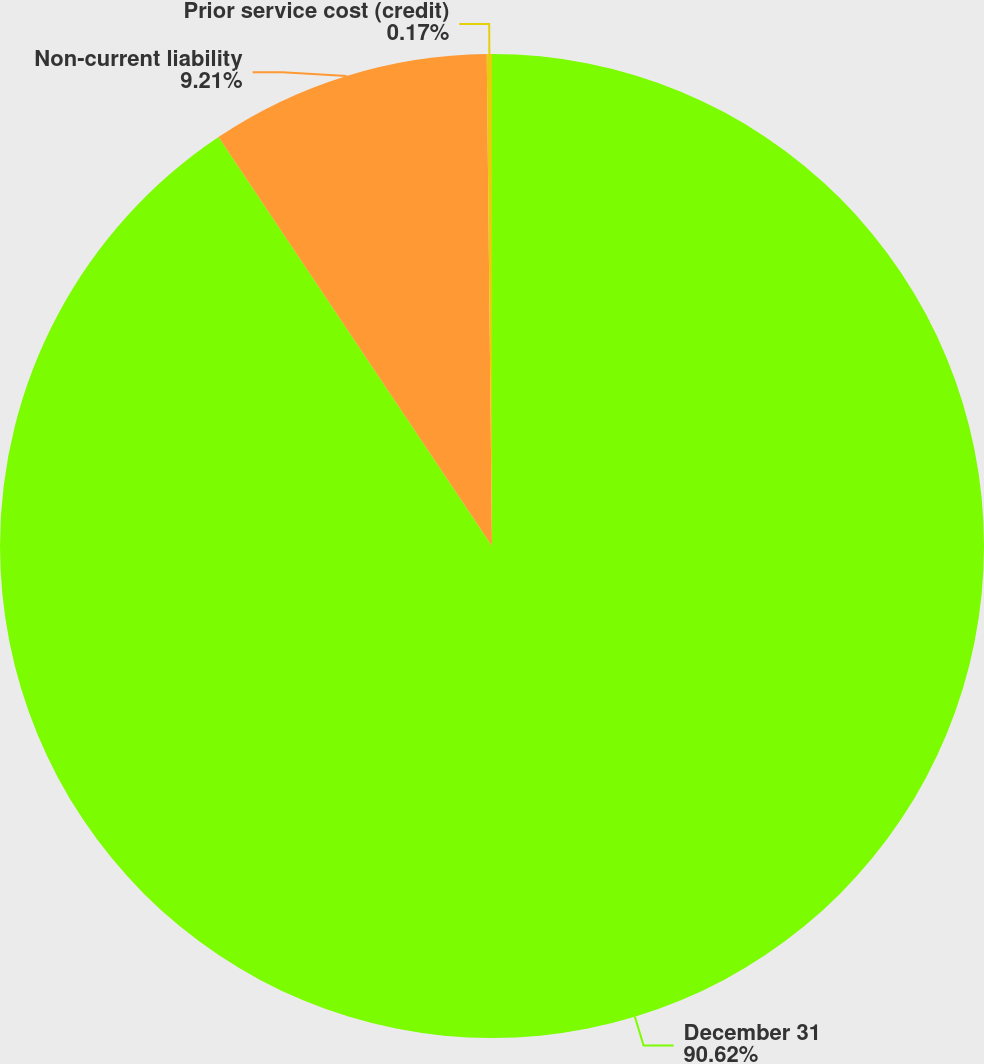Convert chart to OTSL. <chart><loc_0><loc_0><loc_500><loc_500><pie_chart><fcel>December 31<fcel>Non-current liability<fcel>Prior service cost (credit)<nl><fcel>90.62%<fcel>9.21%<fcel>0.17%<nl></chart> 